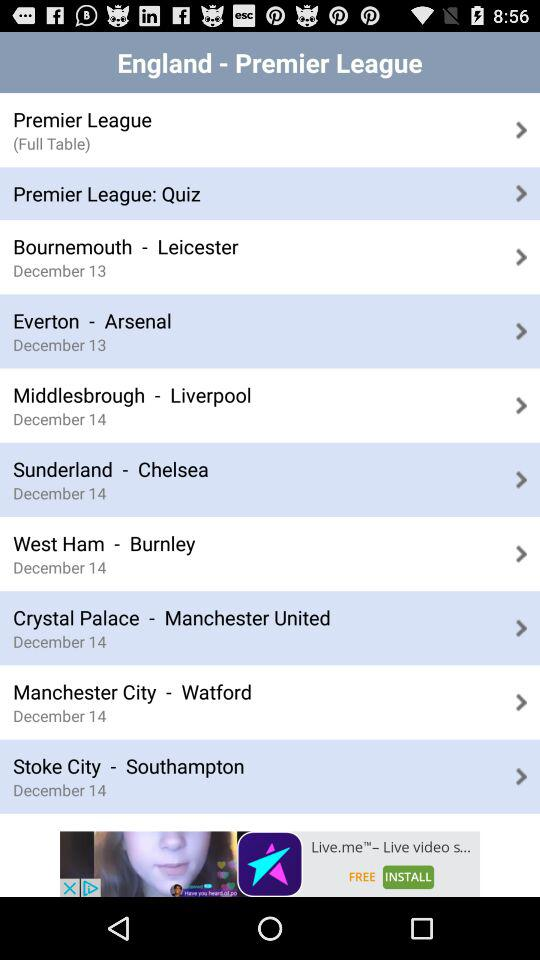What are the teams available in the "England Premier League"? The teams available in the "England Premier League" are : "Bournemouth - Leicester", "Everton - Arsenal", "Middlesbrough - Liverpool", "Sunderland - Chelsea", "West Ham - Burnley", "Crystal Palace - Manchester United", "Manchester City - Watford", and "Stoke City - Southampton". 